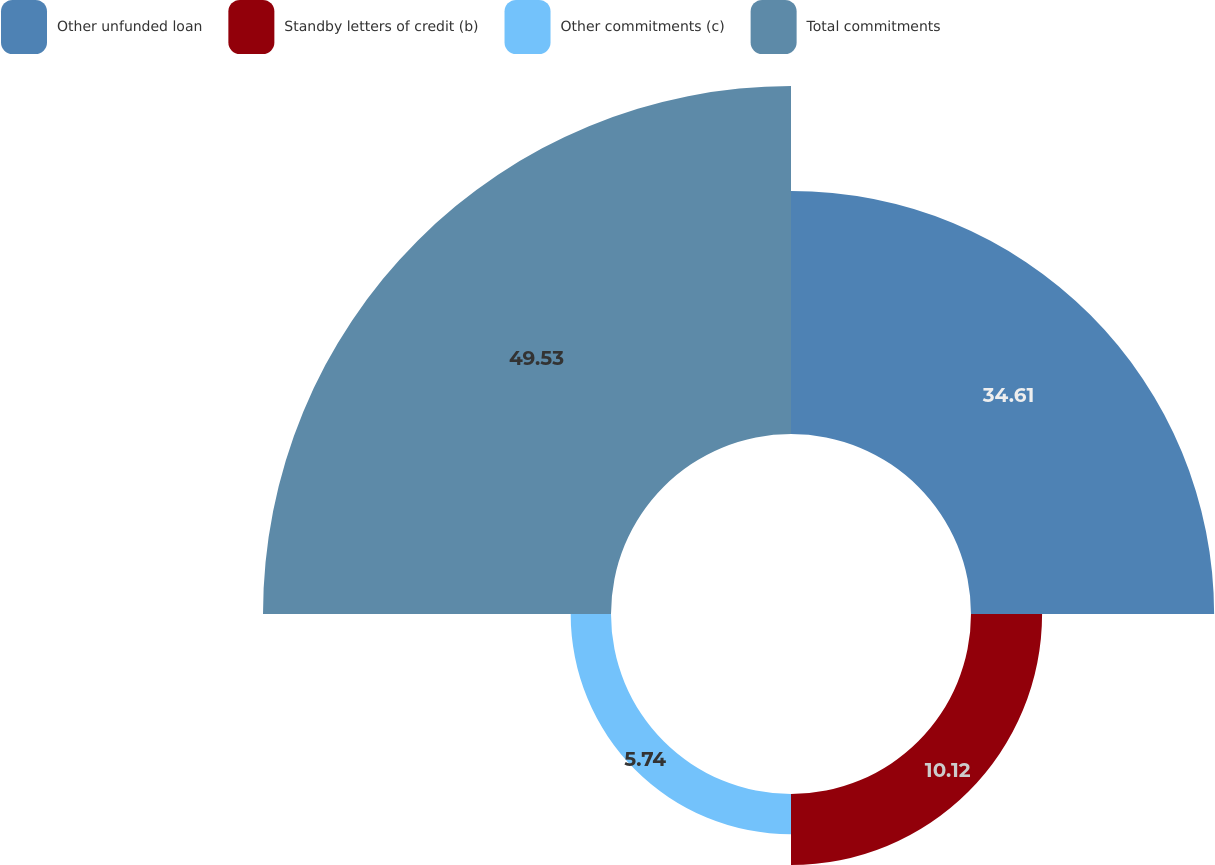Convert chart. <chart><loc_0><loc_0><loc_500><loc_500><pie_chart><fcel>Other unfunded loan<fcel>Standby letters of credit (b)<fcel>Other commitments (c)<fcel>Total commitments<nl><fcel>34.61%<fcel>10.12%<fcel>5.74%<fcel>49.54%<nl></chart> 